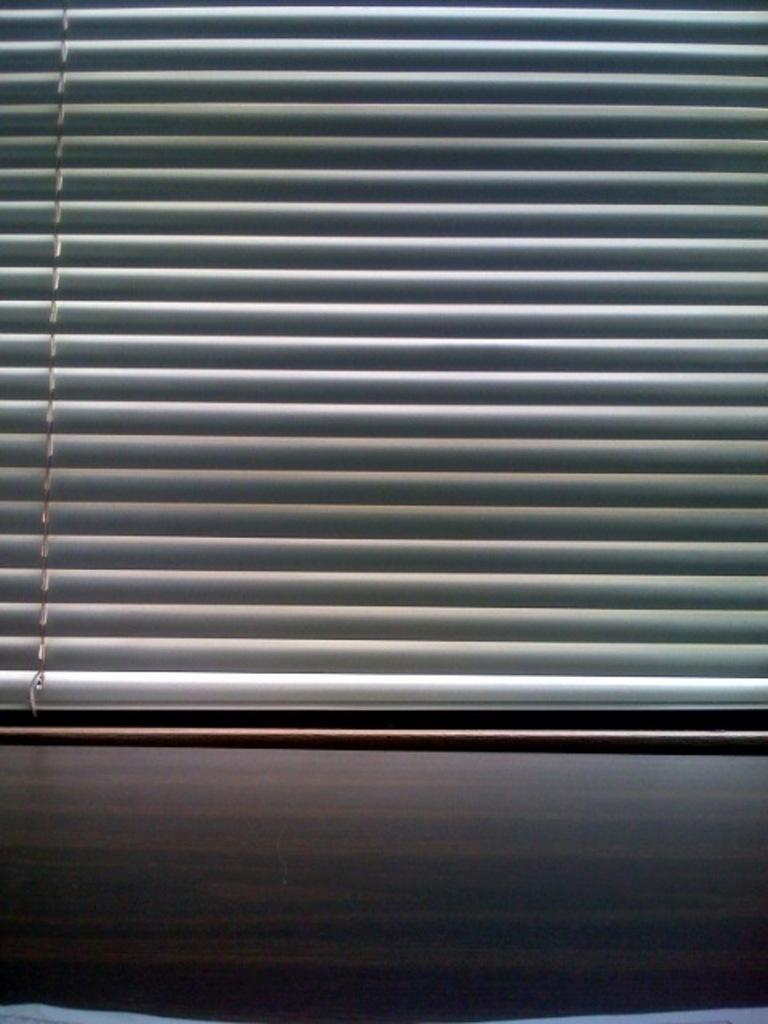What is present in the image related to window coverings? There is a window blind in the image. What type of ornament is hanging from the window blind in the image? There is no ornament hanging from the window blind in the image. Can you hear the horn sound in the image? There is no horn present in the image, so it is not possible to hear any sound. 